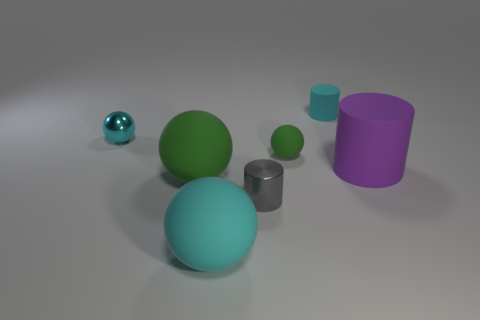There is a big rubber object that is to the right of the big cyan rubber sphere; does it have the same shape as the tiny shiny thing to the right of the small cyan metal object?
Provide a succinct answer. Yes. What number of objects are either tiny cyan cylinders or things that are to the left of the purple cylinder?
Provide a short and direct response. 6. How many other things are the same size as the cyan cylinder?
Give a very brief answer. 3. Does the tiny ball in front of the cyan metallic ball have the same material as the tiny ball left of the tiny gray cylinder?
Make the answer very short. No. There is a large green object; what number of rubber spheres are behind it?
Your answer should be very brief. 1. What number of green objects are either cylinders or small rubber objects?
Offer a very short reply. 1. There is a green object that is the same size as the gray cylinder; what is it made of?
Provide a succinct answer. Rubber. What shape is the large thing that is on the left side of the big purple cylinder and behind the tiny gray cylinder?
Your answer should be compact. Sphere. There is a metallic cylinder that is the same size as the cyan metal thing; what is its color?
Ensure brevity in your answer.  Gray. Does the shiny object right of the tiny cyan metal ball have the same size as the green matte sphere that is behind the big purple matte object?
Keep it short and to the point. Yes. 